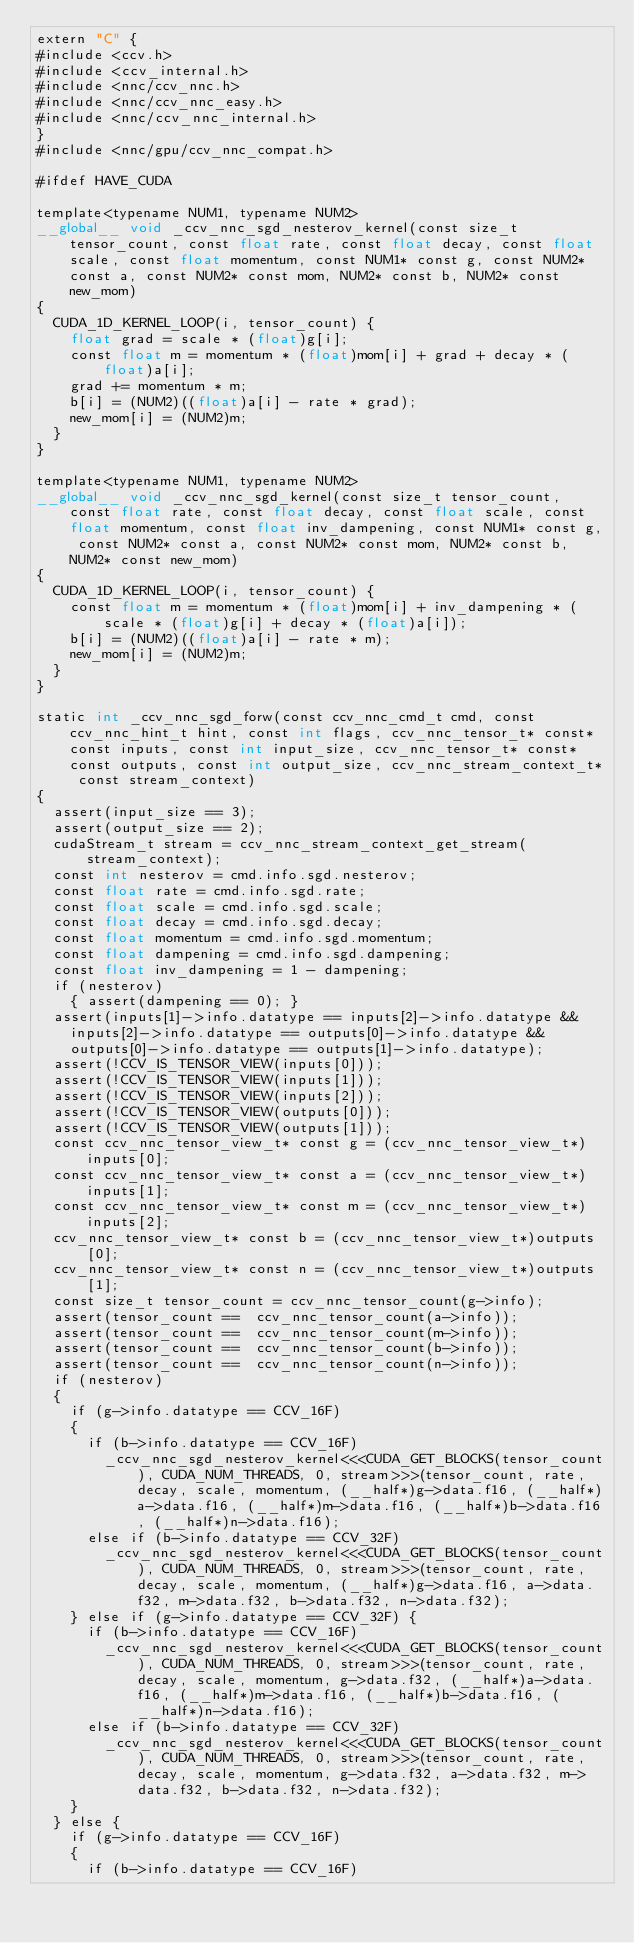<code> <loc_0><loc_0><loc_500><loc_500><_Cuda_>extern "C" {
#include <ccv.h>
#include <ccv_internal.h>
#include <nnc/ccv_nnc.h>
#include <nnc/ccv_nnc_easy.h>
#include <nnc/ccv_nnc_internal.h>
}
#include <nnc/gpu/ccv_nnc_compat.h>

#ifdef HAVE_CUDA

template<typename NUM1, typename NUM2>
__global__ void _ccv_nnc_sgd_nesterov_kernel(const size_t tensor_count, const float rate, const float decay, const float scale, const float momentum, const NUM1* const g, const NUM2* const a, const NUM2* const mom, NUM2* const b, NUM2* const new_mom)
{
	CUDA_1D_KERNEL_LOOP(i, tensor_count) {
		float grad = scale * (float)g[i];
		const float m = momentum * (float)mom[i] + grad + decay * (float)a[i];
		grad += momentum * m;
		b[i] = (NUM2)((float)a[i] - rate * grad);
		new_mom[i] = (NUM2)m;
	}
}

template<typename NUM1, typename NUM2>
__global__ void _ccv_nnc_sgd_kernel(const size_t tensor_count, const float rate, const float decay, const float scale, const float momentum, const float inv_dampening, const NUM1* const g, const NUM2* const a, const NUM2* const mom, NUM2* const b, NUM2* const new_mom)
{
	CUDA_1D_KERNEL_LOOP(i, tensor_count) {
		const float m = momentum * (float)mom[i] + inv_dampening * (scale * (float)g[i] + decay * (float)a[i]);
		b[i] = (NUM2)((float)a[i] - rate * m);
		new_mom[i] = (NUM2)m;
	}
}

static int _ccv_nnc_sgd_forw(const ccv_nnc_cmd_t cmd, const ccv_nnc_hint_t hint, const int flags, ccv_nnc_tensor_t* const* const inputs, const int input_size, ccv_nnc_tensor_t* const* const outputs, const int output_size, ccv_nnc_stream_context_t* const stream_context)
{
	assert(input_size == 3);
	assert(output_size == 2);
	cudaStream_t stream = ccv_nnc_stream_context_get_stream(stream_context);
	const int nesterov = cmd.info.sgd.nesterov;
	const float rate = cmd.info.sgd.rate;
	const float scale = cmd.info.sgd.scale;
	const float decay = cmd.info.sgd.decay;
	const float momentum = cmd.info.sgd.momentum;
	const float dampening = cmd.info.sgd.dampening;
	const float inv_dampening = 1 - dampening;
	if (nesterov)
		{ assert(dampening == 0); }
	assert(inputs[1]->info.datatype == inputs[2]->info.datatype &&
		inputs[2]->info.datatype == outputs[0]->info.datatype &&
		outputs[0]->info.datatype == outputs[1]->info.datatype);
	assert(!CCV_IS_TENSOR_VIEW(inputs[0]));
	assert(!CCV_IS_TENSOR_VIEW(inputs[1]));
	assert(!CCV_IS_TENSOR_VIEW(inputs[2]));
	assert(!CCV_IS_TENSOR_VIEW(outputs[0]));
	assert(!CCV_IS_TENSOR_VIEW(outputs[1]));
	const ccv_nnc_tensor_view_t* const g = (ccv_nnc_tensor_view_t*)inputs[0];
	const ccv_nnc_tensor_view_t* const a = (ccv_nnc_tensor_view_t*)inputs[1];
	const ccv_nnc_tensor_view_t* const m = (ccv_nnc_tensor_view_t*)inputs[2];
	ccv_nnc_tensor_view_t* const b = (ccv_nnc_tensor_view_t*)outputs[0];
	ccv_nnc_tensor_view_t* const n = (ccv_nnc_tensor_view_t*)outputs[1];
	const size_t tensor_count = ccv_nnc_tensor_count(g->info);
	assert(tensor_count ==  ccv_nnc_tensor_count(a->info));
	assert(tensor_count ==  ccv_nnc_tensor_count(m->info));
	assert(tensor_count ==  ccv_nnc_tensor_count(b->info));
	assert(tensor_count ==  ccv_nnc_tensor_count(n->info));
	if (nesterov)
	{
		if (g->info.datatype == CCV_16F)
		{
			if (b->info.datatype == CCV_16F)
				_ccv_nnc_sgd_nesterov_kernel<<<CUDA_GET_BLOCKS(tensor_count), CUDA_NUM_THREADS, 0, stream>>>(tensor_count, rate, decay, scale, momentum, (__half*)g->data.f16, (__half*)a->data.f16, (__half*)m->data.f16, (__half*)b->data.f16, (__half*)n->data.f16);
			else if (b->info.datatype == CCV_32F)
				_ccv_nnc_sgd_nesterov_kernel<<<CUDA_GET_BLOCKS(tensor_count), CUDA_NUM_THREADS, 0, stream>>>(tensor_count, rate, decay, scale, momentum, (__half*)g->data.f16, a->data.f32, m->data.f32, b->data.f32, n->data.f32);
		} else if (g->info.datatype == CCV_32F) {
			if (b->info.datatype == CCV_16F)
				_ccv_nnc_sgd_nesterov_kernel<<<CUDA_GET_BLOCKS(tensor_count), CUDA_NUM_THREADS, 0, stream>>>(tensor_count, rate, decay, scale, momentum, g->data.f32, (__half*)a->data.f16, (__half*)m->data.f16, (__half*)b->data.f16, (__half*)n->data.f16);
			else if (b->info.datatype == CCV_32F)
				_ccv_nnc_sgd_nesterov_kernel<<<CUDA_GET_BLOCKS(tensor_count), CUDA_NUM_THREADS, 0, stream>>>(tensor_count, rate, decay, scale, momentum, g->data.f32, a->data.f32, m->data.f32, b->data.f32, n->data.f32);
		}
	} else {
		if (g->info.datatype == CCV_16F)
		{
			if (b->info.datatype == CCV_16F)</code> 